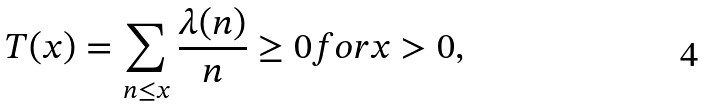Convert formula to latex. <formula><loc_0><loc_0><loc_500><loc_500>T ( x ) = \sum _ { n \leq x } { \frac { \lambda ( n ) } { n } } \geq 0 { f o r } x > 0 ,</formula> 